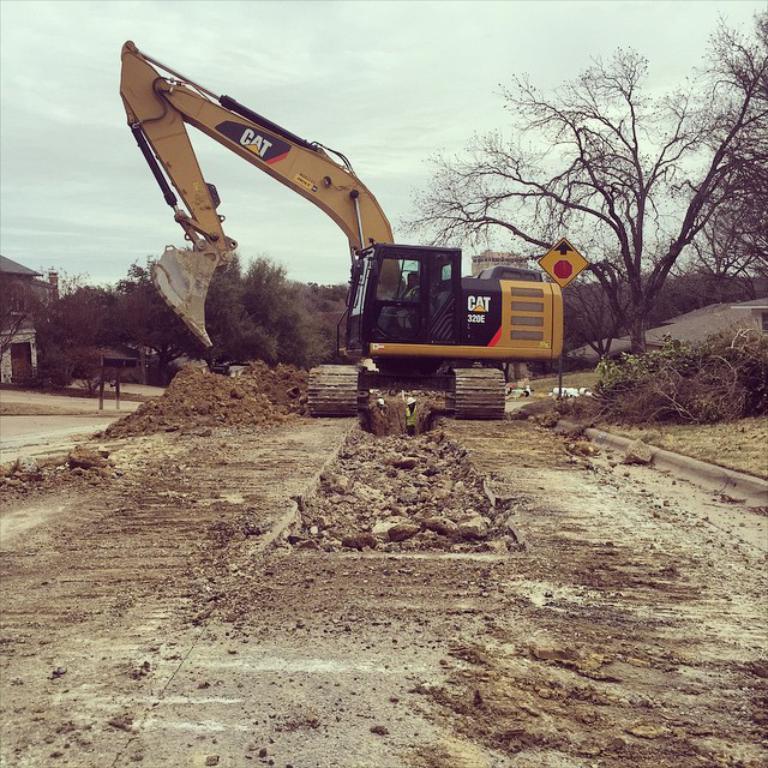In one or two sentences, can you explain what this image depicts? In the image there is a person sitting inside a crane ploughing soil from the land, in the back there are trees and above its sky. 